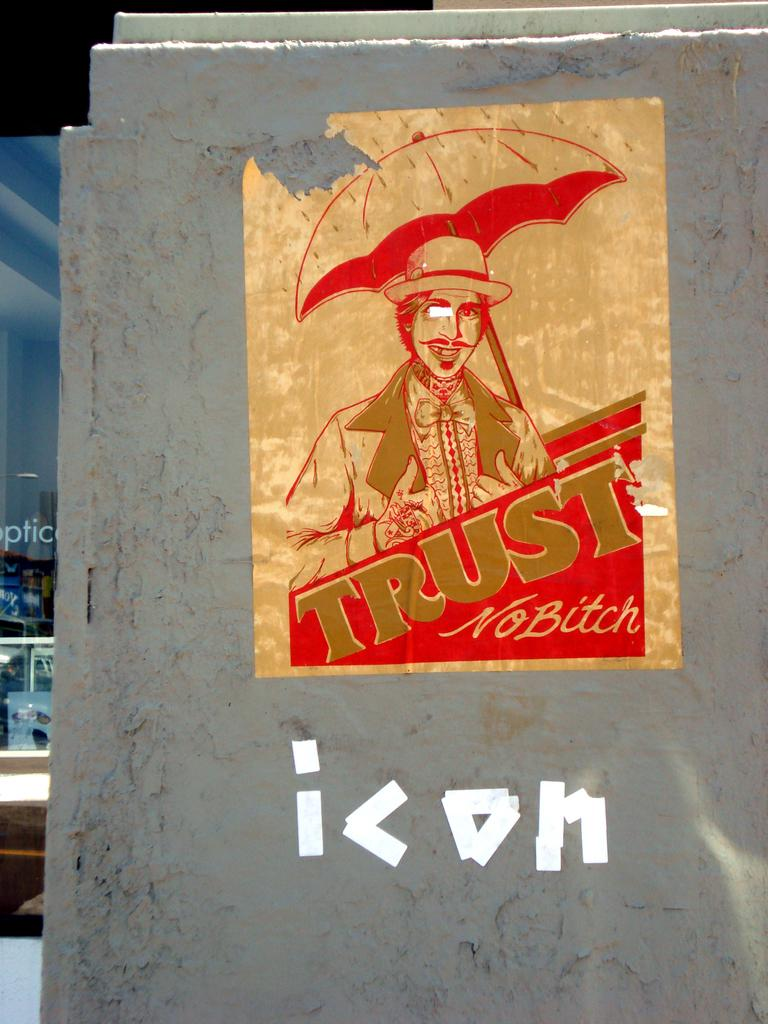<image>
Share a concise interpretation of the image provided. An old poster that reads Trust No Bitch over top of the word "icon" written with white tape. 